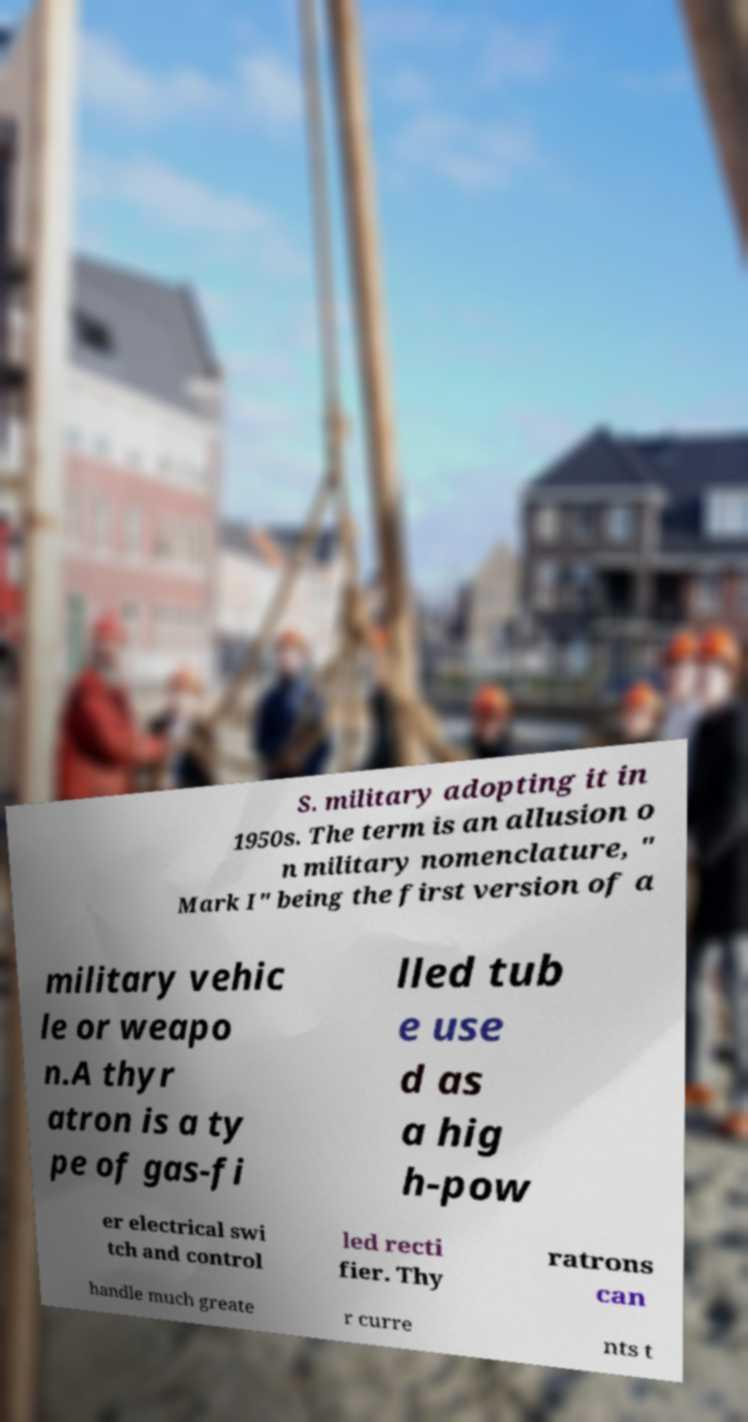There's text embedded in this image that I need extracted. Can you transcribe it verbatim? S. military adopting it in 1950s. The term is an allusion o n military nomenclature, " Mark I" being the first version of a military vehic le or weapo n.A thyr atron is a ty pe of gas-fi lled tub e use d as a hig h-pow er electrical swi tch and control led recti fier. Thy ratrons can handle much greate r curre nts t 